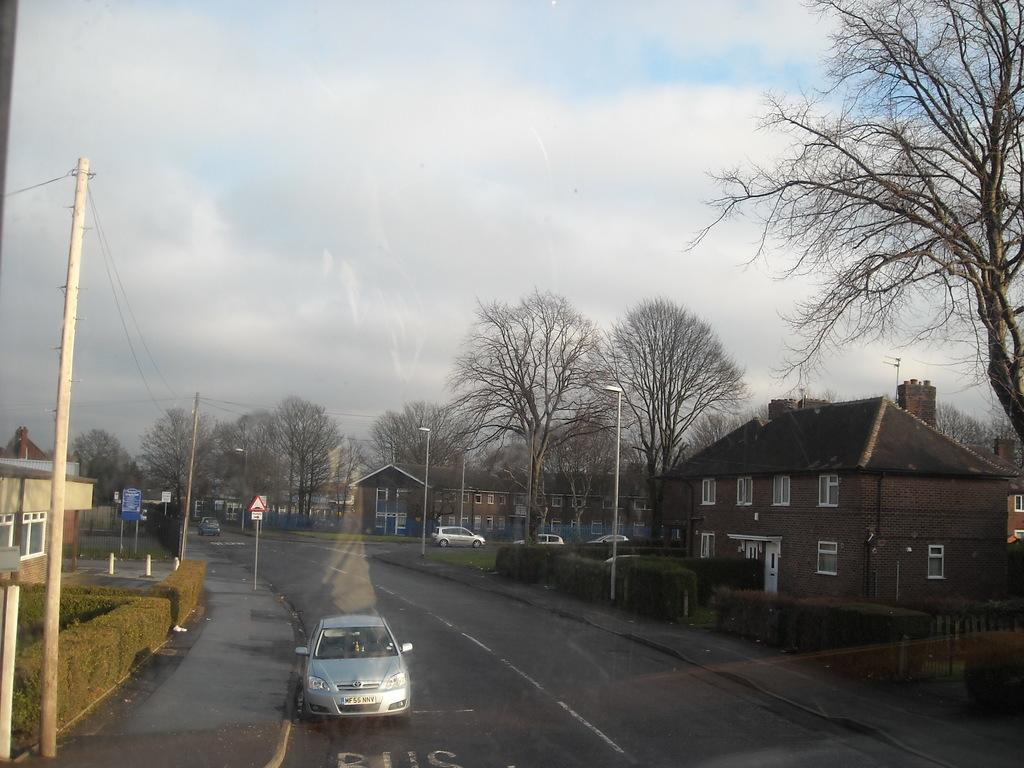What can be seen on the road in the image? There are vehicles on the road in the image. What type of structures are visible in the image? There are houses in the image. What architectural feature can be seen in the image? Windows are visible in the image. What type of vegetation is present in the image? Plants and dried trees are visible in the image. What utility structures can be seen in the image? Electrical poles are in the image. What type of lighting is present in the image? Street lights are present in the image. What is visible at the top of the image? The sky is visible at the top of the image. What can be seen in the sky? Clouds are present in the sky. Can you tell me how many rats are climbing the electrical poles in the image? There are no rats present in the image; it features vehicles on the road, houses, windows, plants, dried trees, electrical poles, street lights, and a sky with clouds. What type of achievement is the army celebrating in the image? There is no army or achievement present in the image; it focuses on the road, houses, windows, plants, dried trees, electrical poles, street lights, and the sky with clouds. 